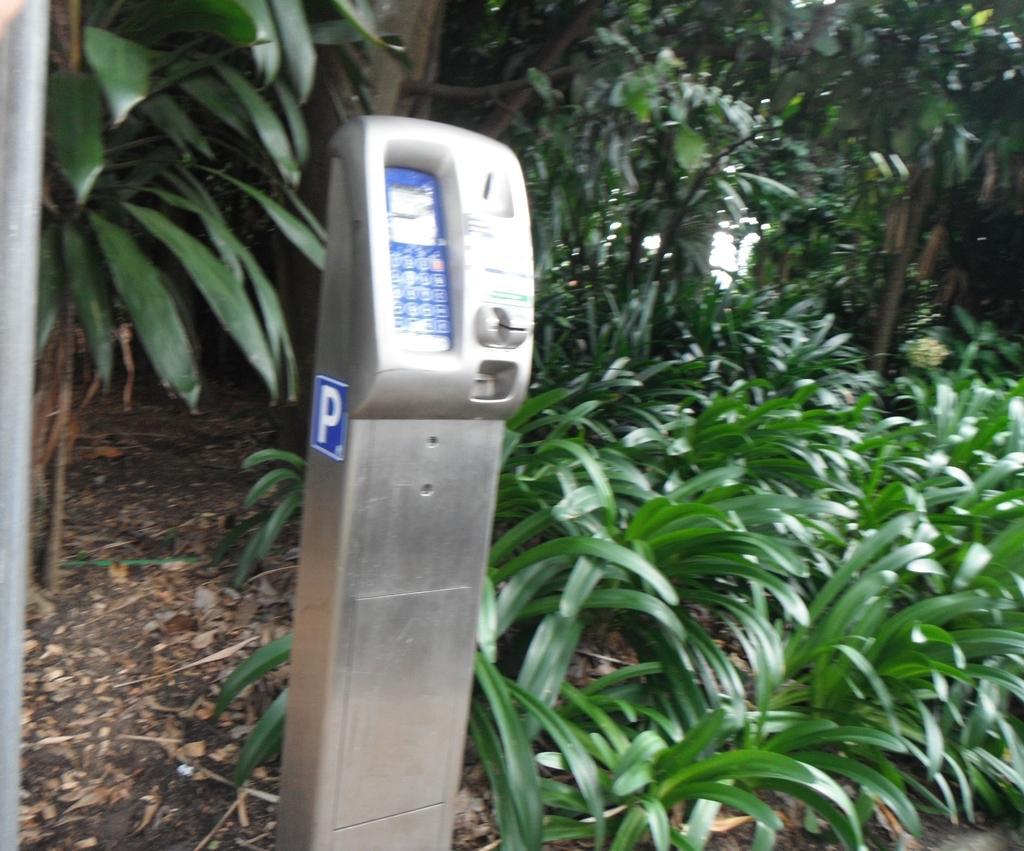Could you give a brief overview of what you see in this image? In this picture we can see plants and green leaves. There are dried leaves on the ground. This picture is mainly highlighted with a parking machine. 